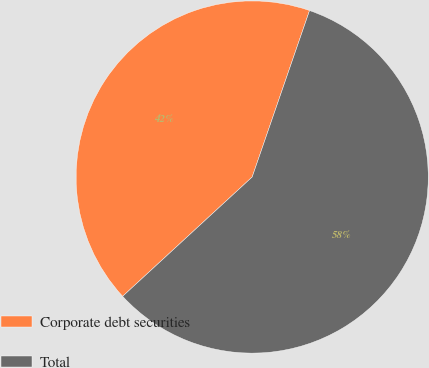<chart> <loc_0><loc_0><loc_500><loc_500><pie_chart><fcel>Corporate debt securities<fcel>Total<nl><fcel>42.13%<fcel>57.87%<nl></chart> 